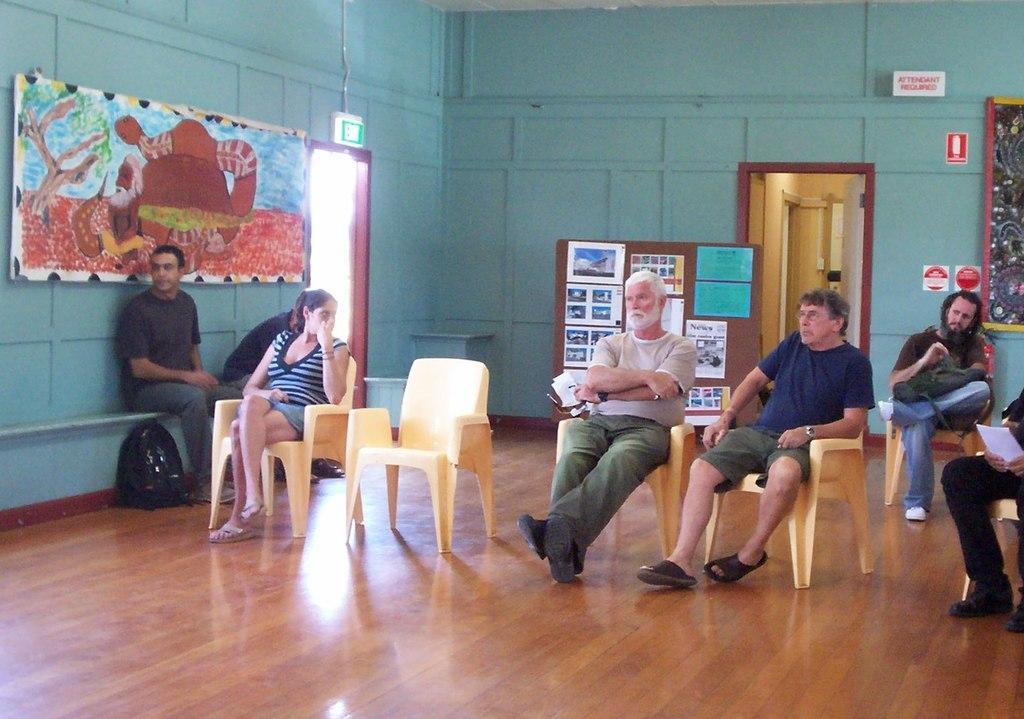In one or two sentences, can you explain what this image depicts? There are lot of people sitting on chairs and on left wall there is a painting and access. At there back there is a display board and some notice on it. 